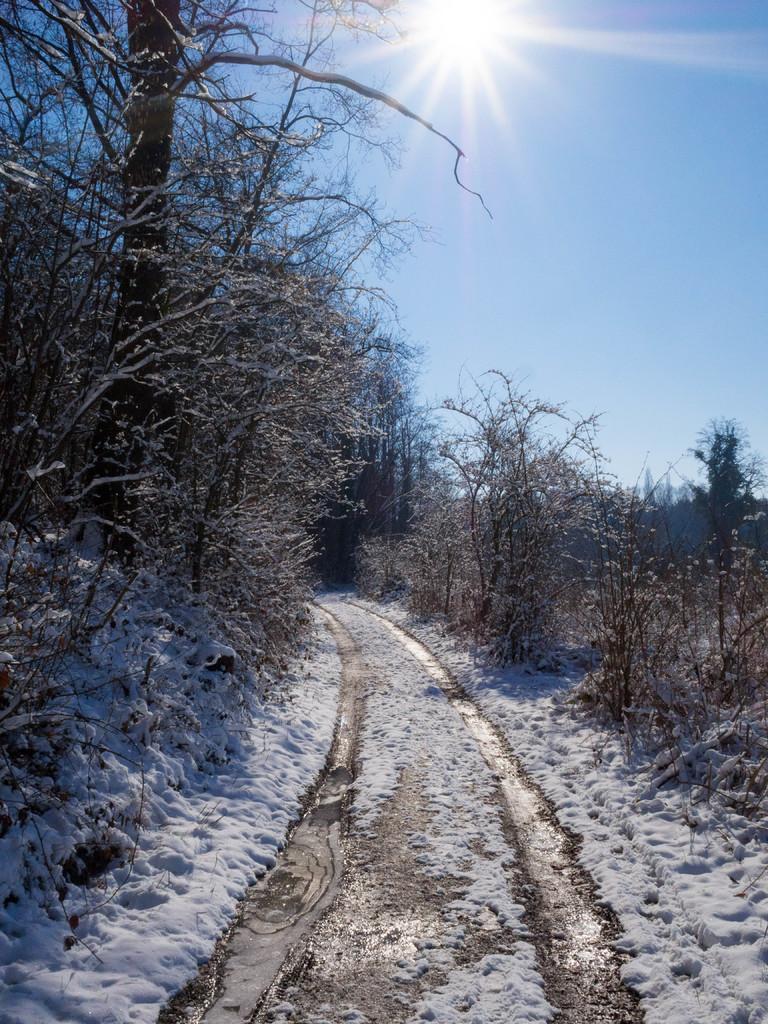Please provide a concise description of this image. At the bottom of the picture, we see the road which is covered with ice. On either side of the picture, there are trees. There are trees in the background. At the top of the picture, we see the sky and the sun. 